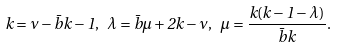Convert formula to latex. <formula><loc_0><loc_0><loc_500><loc_500>k = \nu - \bar { b } { k } - 1 , \ \lambda = \bar { b } { \mu } + 2 k - \nu , \ \mu = \frac { k ( k - 1 - \lambda ) } { \bar { b } { k } } .</formula> 